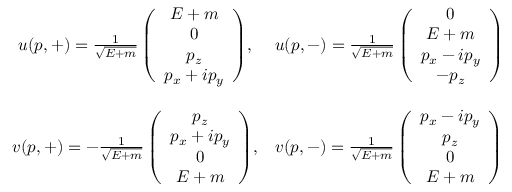Convert formula to latex. <formula><loc_0><loc_0><loc_500><loc_500>\begin{array} { c c } { { u ( p , + ) = { \frac { 1 } { \sqrt { E + m } } \left ( \begin{array} { c } { E + m } \\ { 0 } \\ { { p _ { z } } } \\ { { p _ { x } + i p _ { y } } } \end{array} \right ) } , } } & { { u ( p , - ) = { \frac { 1 } { \sqrt { E + m } } \left ( \begin{array} { c } { 0 } \\ { E + m } \\ { { p _ { x } - i p _ { y } } } \\ { { - p _ { z } } } \end{array} \right ) } } } \\ { { v ( p , + ) = { - \frac { 1 } { \sqrt { E + m } } \left ( \begin{array} { c } { { p _ { z } } } \\ { { p _ { x } + i p _ { y } } } \\ { 0 } \\ { E + m } \end{array} \right ) } , } } & { { v ( p , - ) = { \frac { 1 } { \sqrt { E + m } } \left ( \begin{array} { c } { { p _ { x } - i p _ { y } } } \\ { { p _ { z } } } \\ { 0 } \\ { E + m } \end{array} \right ) } } } \end{array}</formula> 